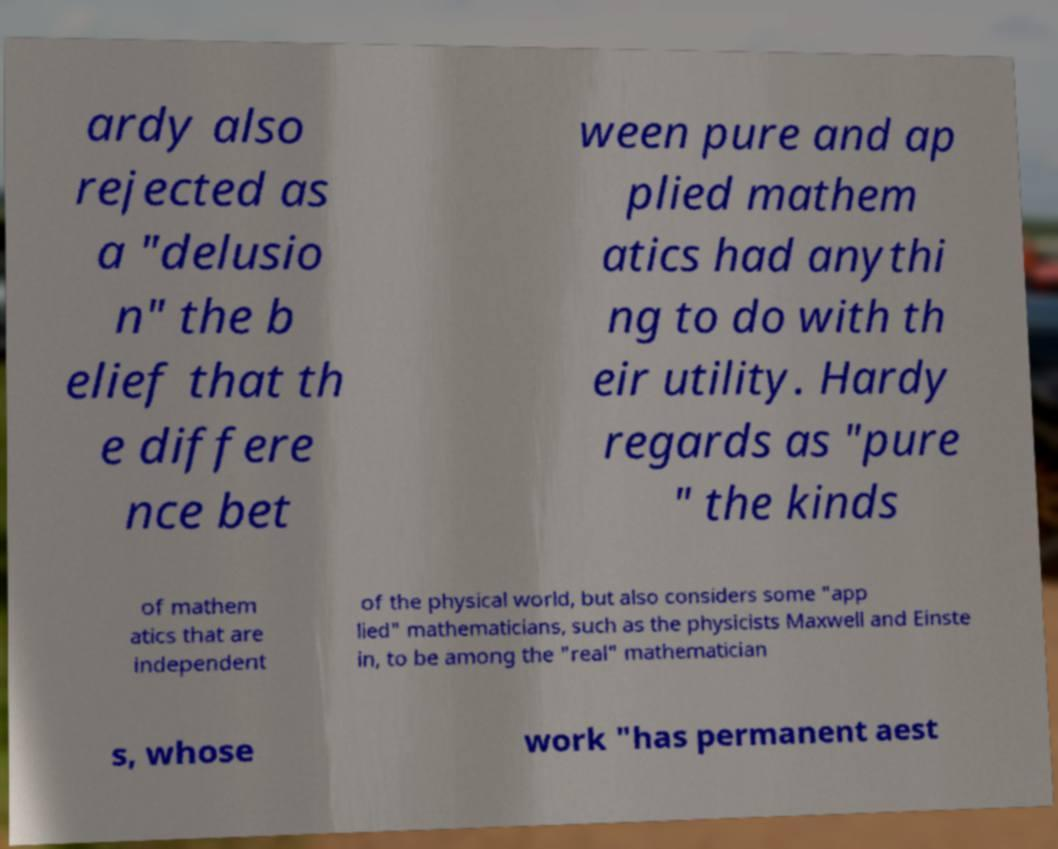Please identify and transcribe the text found in this image. ardy also rejected as a "delusio n" the b elief that th e differe nce bet ween pure and ap plied mathem atics had anythi ng to do with th eir utility. Hardy regards as "pure " the kinds of mathem atics that are independent of the physical world, but also considers some "app lied" mathematicians, such as the physicists Maxwell and Einste in, to be among the "real" mathematician s, whose work "has permanent aest 